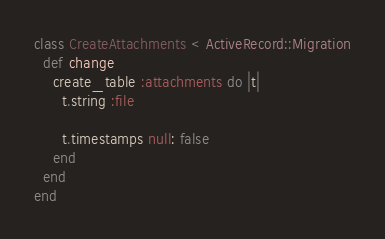Convert code to text. <code><loc_0><loc_0><loc_500><loc_500><_Ruby_>class CreateAttachments < ActiveRecord::Migration
  def change
    create_table :attachments do |t|
      t.string :file

      t.timestamps null: false
    end
  end
end
</code> 